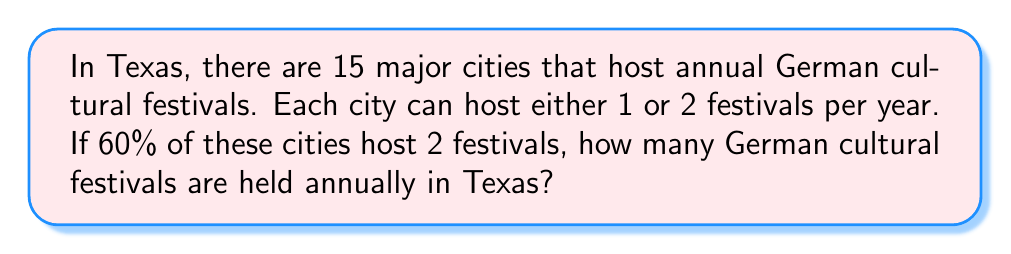Help me with this question. Let's approach this step-by-step:

1) First, we need to determine how many cities host 2 festivals and how many host 1 festival.
   - Total number of cities: 15
   - Percentage of cities hosting 2 festivals: 60% = 0.60
   
2) Calculate the number of cities hosting 2 festivals:
   $$ 15 \times 0.60 = 9 \text{ cities} $$

3) The remaining cities host 1 festival each:
   $$ 15 - 9 = 6 \text{ cities} $$

4) Now, let's calculate the total number of festivals:
   - Festivals from cities hosting 2: $9 \times 2 = 18$
   - Festivals from cities hosting 1: $6 \times 1 = 6$

5) Sum up the total number of festivals:
   $$ 18 + 6 = 24 \text{ festivals} $$

Therefore, there are 24 German cultural festivals held annually in Texas.
Answer: 24 festivals 